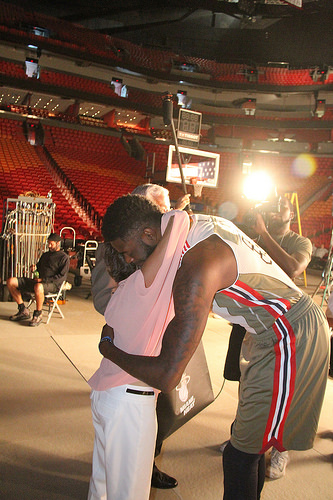<image>
Can you confirm if the boy is on the man? Yes. Looking at the image, I can see the boy is positioned on top of the man, with the man providing support. 